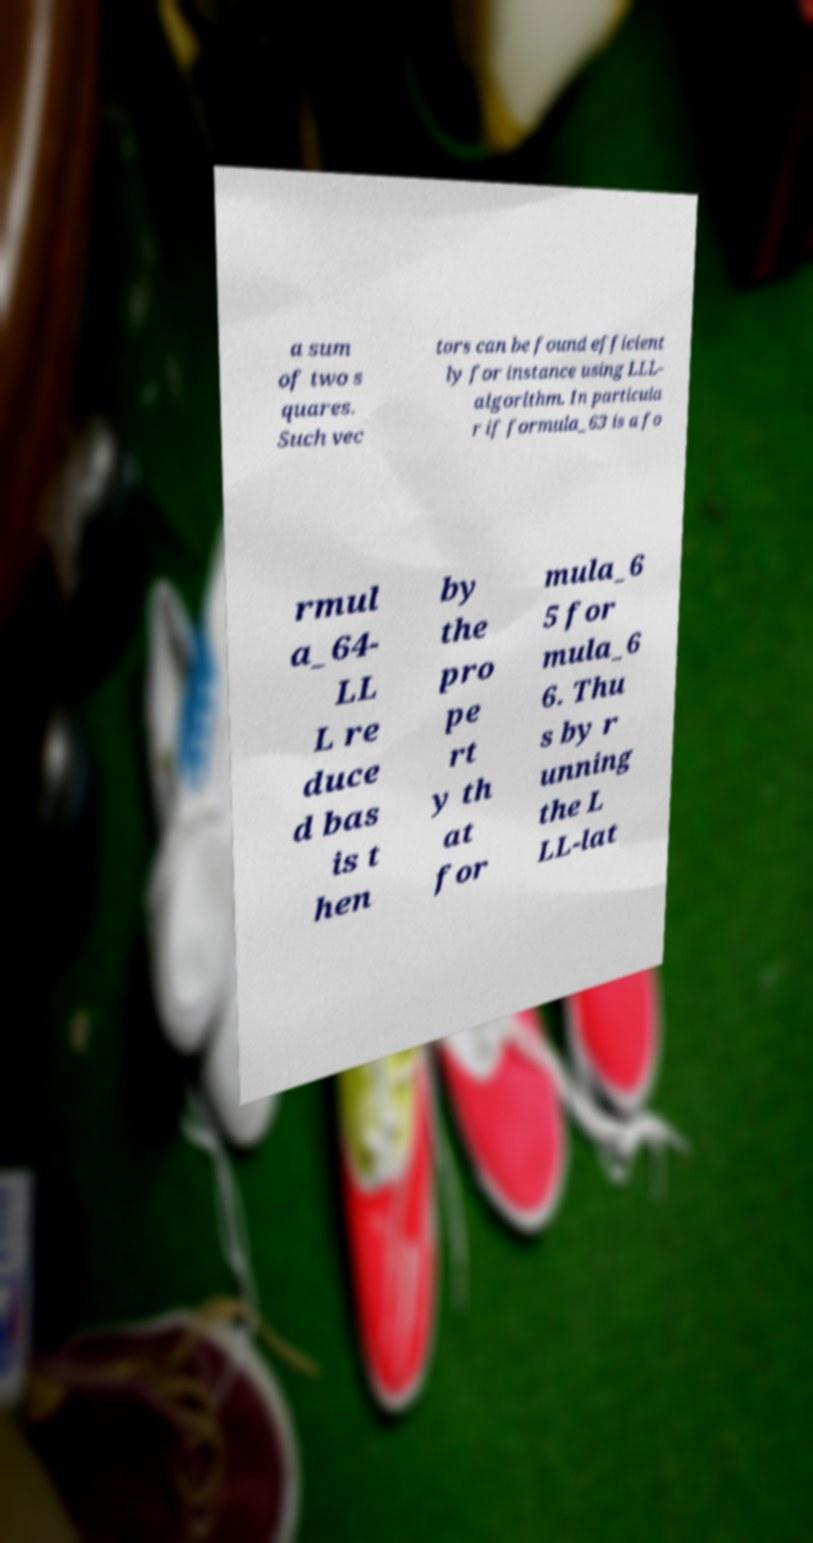Please read and relay the text visible in this image. What does it say? a sum of two s quares. Such vec tors can be found efficient ly for instance using LLL- algorithm. In particula r if formula_63 is a fo rmul a_64- LL L re duce d bas is t hen by the pro pe rt y th at for mula_6 5 for mula_6 6. Thu s by r unning the L LL-lat 